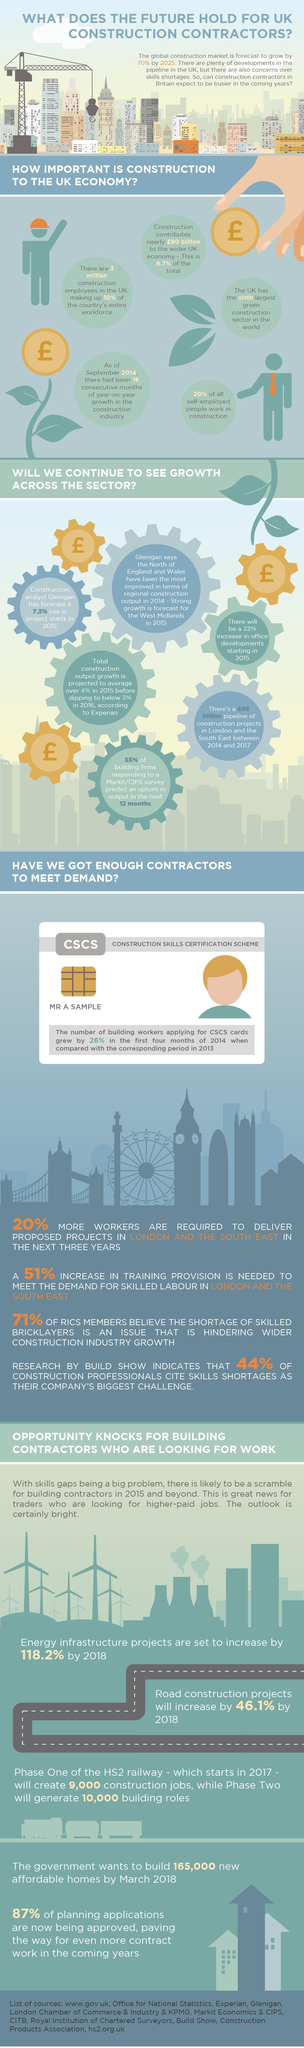Mention a couple of crucial points in this snapshot. The expected growth of offices in the UK in 2015 was projected to be approximately 23%. The United Kingdom has secured the sixth position in the green construction sector. According to a recent survey, approximately 80% of all self-occupied individuals do not work in the construction sector. 